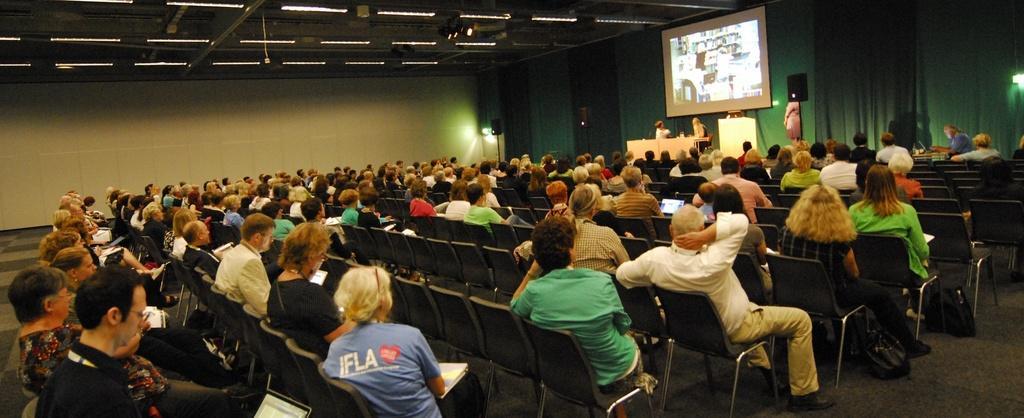Could you give a brief overview of what you see in this image? In this image there are people sitting on chairs, in front of them there is a stage on that stage, there are two people sitting on chairs and there is a table and a woman standing, in the background there is a curtain, at the top there are lights. 